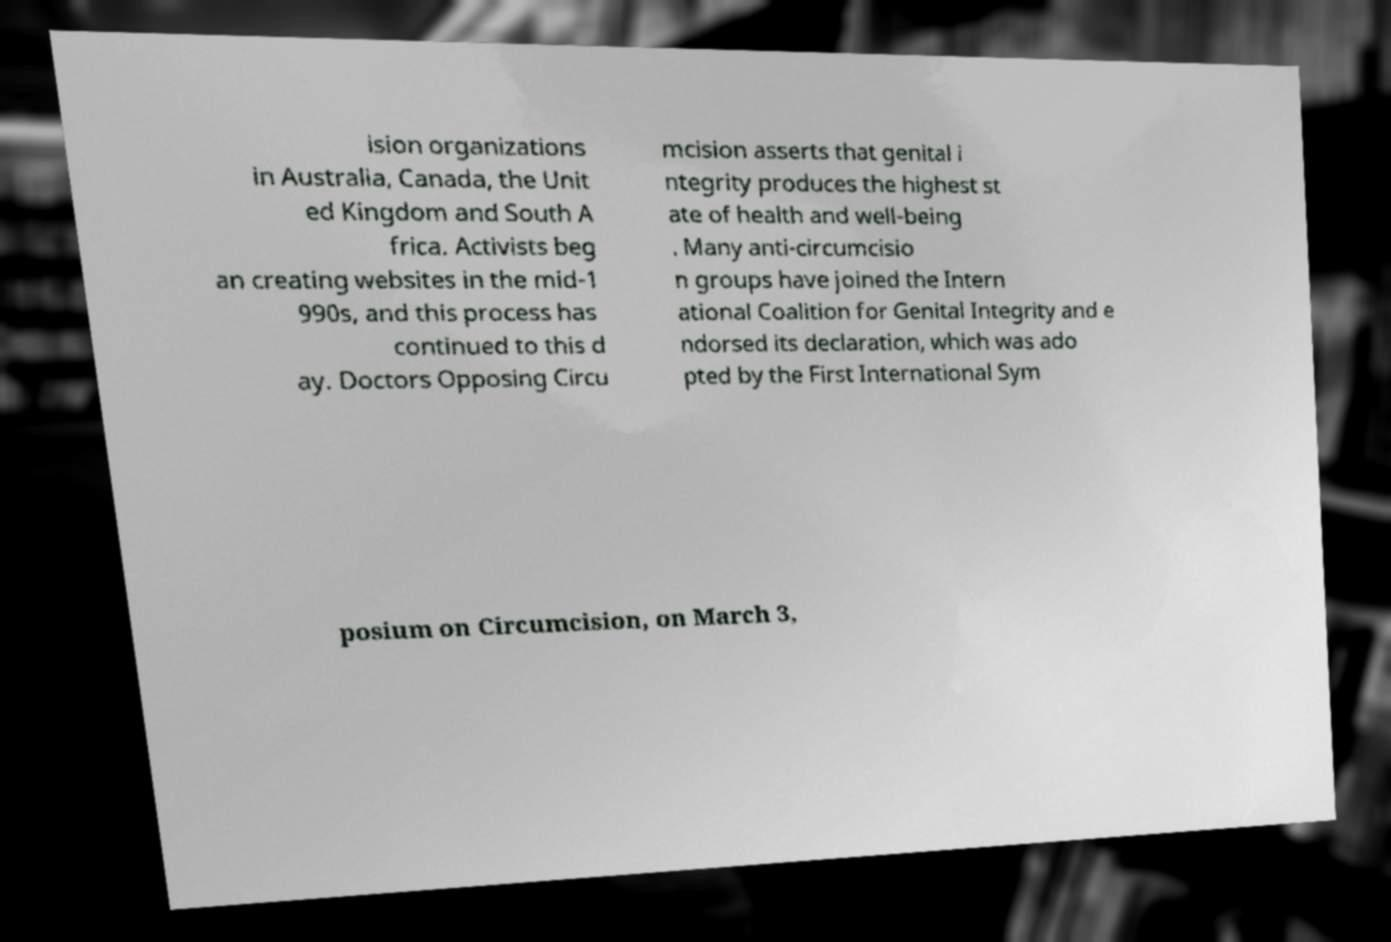There's text embedded in this image that I need extracted. Can you transcribe it verbatim? ision organizations in Australia, Canada, the Unit ed Kingdom and South A frica. Activists beg an creating websites in the mid-1 990s, and this process has continued to this d ay. Doctors Opposing Circu mcision asserts that genital i ntegrity produces the highest st ate of health and well-being . Many anti-circumcisio n groups have joined the Intern ational Coalition for Genital Integrity and e ndorsed its declaration, which was ado pted by the First International Sym posium on Circumcision, on March 3, 